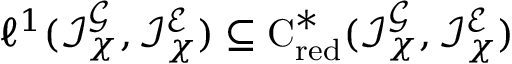<formula> <loc_0><loc_0><loc_500><loc_500>{ \ell ^ { 1 } } ( \mathcal { I } _ { \chi } ^ { { \mathcal { G } } } , \mathcal { I } _ { \chi } ^ { { \mathcal { E } } } ) \subseteq { { C ^ { * } } _ { r e d } } ( \mathcal { I } _ { \chi } ^ { { \mathcal { G } } } , \mathcal { I } _ { \chi } ^ { { \mathcal { E } } } )</formula> 